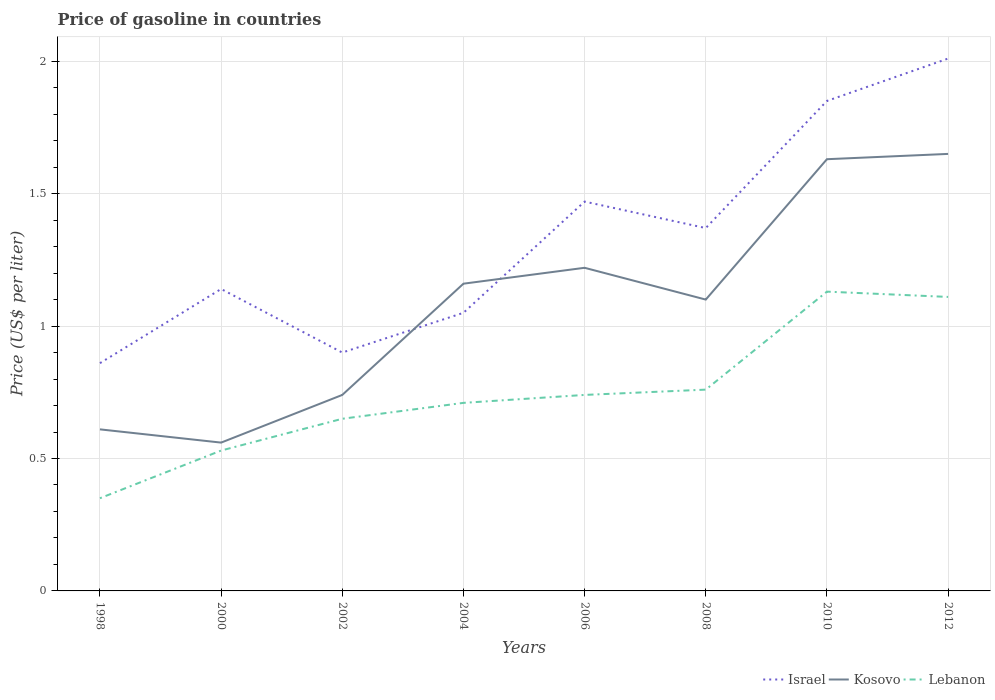How many different coloured lines are there?
Your answer should be very brief. 3. Is the number of lines equal to the number of legend labels?
Give a very brief answer. Yes. Across all years, what is the maximum price of gasoline in Israel?
Provide a short and direct response. 0.86. What is the total price of gasoline in Kosovo in the graph?
Make the answer very short. -1.02. What is the difference between the highest and the second highest price of gasoline in Israel?
Your answer should be very brief. 1.15. What is the difference between the highest and the lowest price of gasoline in Kosovo?
Give a very brief answer. 5. Is the price of gasoline in Lebanon strictly greater than the price of gasoline in Kosovo over the years?
Make the answer very short. Yes. How many lines are there?
Your answer should be compact. 3. What is the difference between two consecutive major ticks on the Y-axis?
Provide a succinct answer. 0.5. Are the values on the major ticks of Y-axis written in scientific E-notation?
Offer a very short reply. No. Does the graph contain any zero values?
Your answer should be very brief. No. Does the graph contain grids?
Keep it short and to the point. Yes. Where does the legend appear in the graph?
Give a very brief answer. Bottom right. How many legend labels are there?
Provide a succinct answer. 3. How are the legend labels stacked?
Your answer should be compact. Horizontal. What is the title of the graph?
Provide a short and direct response. Price of gasoline in countries. Does "Spain" appear as one of the legend labels in the graph?
Your answer should be very brief. No. What is the label or title of the X-axis?
Offer a terse response. Years. What is the label or title of the Y-axis?
Your response must be concise. Price (US$ per liter). What is the Price (US$ per liter) of Israel in 1998?
Give a very brief answer. 0.86. What is the Price (US$ per liter) of Kosovo in 1998?
Make the answer very short. 0.61. What is the Price (US$ per liter) of Israel in 2000?
Make the answer very short. 1.14. What is the Price (US$ per liter) of Kosovo in 2000?
Provide a succinct answer. 0.56. What is the Price (US$ per liter) of Lebanon in 2000?
Ensure brevity in your answer.  0.53. What is the Price (US$ per liter) of Kosovo in 2002?
Your response must be concise. 0.74. What is the Price (US$ per liter) in Lebanon in 2002?
Make the answer very short. 0.65. What is the Price (US$ per liter) in Israel in 2004?
Your response must be concise. 1.05. What is the Price (US$ per liter) of Kosovo in 2004?
Your answer should be compact. 1.16. What is the Price (US$ per liter) of Lebanon in 2004?
Provide a succinct answer. 0.71. What is the Price (US$ per liter) of Israel in 2006?
Your response must be concise. 1.47. What is the Price (US$ per liter) in Kosovo in 2006?
Offer a very short reply. 1.22. What is the Price (US$ per liter) of Lebanon in 2006?
Keep it short and to the point. 0.74. What is the Price (US$ per liter) in Israel in 2008?
Make the answer very short. 1.37. What is the Price (US$ per liter) in Lebanon in 2008?
Make the answer very short. 0.76. What is the Price (US$ per liter) in Israel in 2010?
Provide a short and direct response. 1.85. What is the Price (US$ per liter) in Kosovo in 2010?
Your answer should be very brief. 1.63. What is the Price (US$ per liter) of Lebanon in 2010?
Your answer should be very brief. 1.13. What is the Price (US$ per liter) in Israel in 2012?
Your answer should be very brief. 2.01. What is the Price (US$ per liter) of Kosovo in 2012?
Give a very brief answer. 1.65. What is the Price (US$ per liter) in Lebanon in 2012?
Your answer should be compact. 1.11. Across all years, what is the maximum Price (US$ per liter) in Israel?
Your answer should be compact. 2.01. Across all years, what is the maximum Price (US$ per liter) of Kosovo?
Your response must be concise. 1.65. Across all years, what is the maximum Price (US$ per liter) of Lebanon?
Offer a terse response. 1.13. Across all years, what is the minimum Price (US$ per liter) of Israel?
Offer a very short reply. 0.86. Across all years, what is the minimum Price (US$ per liter) in Kosovo?
Offer a terse response. 0.56. What is the total Price (US$ per liter) in Israel in the graph?
Offer a very short reply. 10.65. What is the total Price (US$ per liter) of Kosovo in the graph?
Provide a short and direct response. 8.67. What is the total Price (US$ per liter) of Lebanon in the graph?
Your answer should be very brief. 5.98. What is the difference between the Price (US$ per liter) in Israel in 1998 and that in 2000?
Provide a short and direct response. -0.28. What is the difference between the Price (US$ per liter) in Kosovo in 1998 and that in 2000?
Provide a short and direct response. 0.05. What is the difference between the Price (US$ per liter) of Lebanon in 1998 and that in 2000?
Offer a very short reply. -0.18. What is the difference between the Price (US$ per liter) of Israel in 1998 and that in 2002?
Make the answer very short. -0.04. What is the difference between the Price (US$ per liter) in Kosovo in 1998 and that in 2002?
Keep it short and to the point. -0.13. What is the difference between the Price (US$ per liter) of Israel in 1998 and that in 2004?
Keep it short and to the point. -0.19. What is the difference between the Price (US$ per liter) of Kosovo in 1998 and that in 2004?
Your answer should be compact. -0.55. What is the difference between the Price (US$ per liter) in Lebanon in 1998 and that in 2004?
Keep it short and to the point. -0.36. What is the difference between the Price (US$ per liter) of Israel in 1998 and that in 2006?
Your answer should be very brief. -0.61. What is the difference between the Price (US$ per liter) of Kosovo in 1998 and that in 2006?
Give a very brief answer. -0.61. What is the difference between the Price (US$ per liter) of Lebanon in 1998 and that in 2006?
Provide a short and direct response. -0.39. What is the difference between the Price (US$ per liter) in Israel in 1998 and that in 2008?
Your answer should be compact. -0.51. What is the difference between the Price (US$ per liter) in Kosovo in 1998 and that in 2008?
Your response must be concise. -0.49. What is the difference between the Price (US$ per liter) of Lebanon in 1998 and that in 2008?
Ensure brevity in your answer.  -0.41. What is the difference between the Price (US$ per liter) in Israel in 1998 and that in 2010?
Provide a succinct answer. -0.99. What is the difference between the Price (US$ per liter) of Kosovo in 1998 and that in 2010?
Offer a terse response. -1.02. What is the difference between the Price (US$ per liter) in Lebanon in 1998 and that in 2010?
Provide a succinct answer. -0.78. What is the difference between the Price (US$ per liter) in Israel in 1998 and that in 2012?
Your response must be concise. -1.15. What is the difference between the Price (US$ per liter) in Kosovo in 1998 and that in 2012?
Provide a succinct answer. -1.04. What is the difference between the Price (US$ per liter) in Lebanon in 1998 and that in 2012?
Ensure brevity in your answer.  -0.76. What is the difference between the Price (US$ per liter) of Israel in 2000 and that in 2002?
Offer a very short reply. 0.24. What is the difference between the Price (US$ per liter) of Kosovo in 2000 and that in 2002?
Provide a succinct answer. -0.18. What is the difference between the Price (US$ per liter) in Lebanon in 2000 and that in 2002?
Keep it short and to the point. -0.12. What is the difference between the Price (US$ per liter) in Israel in 2000 and that in 2004?
Provide a short and direct response. 0.09. What is the difference between the Price (US$ per liter) in Lebanon in 2000 and that in 2004?
Provide a short and direct response. -0.18. What is the difference between the Price (US$ per liter) in Israel in 2000 and that in 2006?
Keep it short and to the point. -0.33. What is the difference between the Price (US$ per liter) in Kosovo in 2000 and that in 2006?
Keep it short and to the point. -0.66. What is the difference between the Price (US$ per liter) of Lebanon in 2000 and that in 2006?
Provide a short and direct response. -0.21. What is the difference between the Price (US$ per liter) in Israel in 2000 and that in 2008?
Provide a short and direct response. -0.23. What is the difference between the Price (US$ per liter) of Kosovo in 2000 and that in 2008?
Your response must be concise. -0.54. What is the difference between the Price (US$ per liter) in Lebanon in 2000 and that in 2008?
Provide a succinct answer. -0.23. What is the difference between the Price (US$ per liter) of Israel in 2000 and that in 2010?
Provide a short and direct response. -0.71. What is the difference between the Price (US$ per liter) of Kosovo in 2000 and that in 2010?
Ensure brevity in your answer.  -1.07. What is the difference between the Price (US$ per liter) in Israel in 2000 and that in 2012?
Give a very brief answer. -0.87. What is the difference between the Price (US$ per liter) in Kosovo in 2000 and that in 2012?
Your answer should be very brief. -1.09. What is the difference between the Price (US$ per liter) in Lebanon in 2000 and that in 2012?
Ensure brevity in your answer.  -0.58. What is the difference between the Price (US$ per liter) of Israel in 2002 and that in 2004?
Give a very brief answer. -0.15. What is the difference between the Price (US$ per liter) of Kosovo in 2002 and that in 2004?
Your answer should be compact. -0.42. What is the difference between the Price (US$ per liter) of Lebanon in 2002 and that in 2004?
Your response must be concise. -0.06. What is the difference between the Price (US$ per liter) of Israel in 2002 and that in 2006?
Your answer should be very brief. -0.57. What is the difference between the Price (US$ per liter) in Kosovo in 2002 and that in 2006?
Keep it short and to the point. -0.48. What is the difference between the Price (US$ per liter) in Lebanon in 2002 and that in 2006?
Ensure brevity in your answer.  -0.09. What is the difference between the Price (US$ per liter) in Israel in 2002 and that in 2008?
Provide a short and direct response. -0.47. What is the difference between the Price (US$ per liter) in Kosovo in 2002 and that in 2008?
Provide a succinct answer. -0.36. What is the difference between the Price (US$ per liter) in Lebanon in 2002 and that in 2008?
Offer a very short reply. -0.11. What is the difference between the Price (US$ per liter) of Israel in 2002 and that in 2010?
Keep it short and to the point. -0.95. What is the difference between the Price (US$ per liter) in Kosovo in 2002 and that in 2010?
Give a very brief answer. -0.89. What is the difference between the Price (US$ per liter) of Lebanon in 2002 and that in 2010?
Give a very brief answer. -0.48. What is the difference between the Price (US$ per liter) of Israel in 2002 and that in 2012?
Provide a succinct answer. -1.11. What is the difference between the Price (US$ per liter) of Kosovo in 2002 and that in 2012?
Your response must be concise. -0.91. What is the difference between the Price (US$ per liter) in Lebanon in 2002 and that in 2012?
Offer a very short reply. -0.46. What is the difference between the Price (US$ per liter) of Israel in 2004 and that in 2006?
Your answer should be compact. -0.42. What is the difference between the Price (US$ per liter) in Kosovo in 2004 and that in 2006?
Provide a succinct answer. -0.06. What is the difference between the Price (US$ per liter) in Lebanon in 2004 and that in 2006?
Offer a terse response. -0.03. What is the difference between the Price (US$ per liter) of Israel in 2004 and that in 2008?
Ensure brevity in your answer.  -0.32. What is the difference between the Price (US$ per liter) in Kosovo in 2004 and that in 2008?
Give a very brief answer. 0.06. What is the difference between the Price (US$ per liter) of Lebanon in 2004 and that in 2008?
Keep it short and to the point. -0.05. What is the difference between the Price (US$ per liter) of Kosovo in 2004 and that in 2010?
Provide a succinct answer. -0.47. What is the difference between the Price (US$ per liter) of Lebanon in 2004 and that in 2010?
Provide a short and direct response. -0.42. What is the difference between the Price (US$ per liter) of Israel in 2004 and that in 2012?
Your answer should be very brief. -0.96. What is the difference between the Price (US$ per liter) in Kosovo in 2004 and that in 2012?
Give a very brief answer. -0.49. What is the difference between the Price (US$ per liter) in Lebanon in 2004 and that in 2012?
Your answer should be compact. -0.4. What is the difference between the Price (US$ per liter) of Israel in 2006 and that in 2008?
Your answer should be very brief. 0.1. What is the difference between the Price (US$ per liter) in Kosovo in 2006 and that in 2008?
Provide a short and direct response. 0.12. What is the difference between the Price (US$ per liter) in Lebanon in 2006 and that in 2008?
Give a very brief answer. -0.02. What is the difference between the Price (US$ per liter) in Israel in 2006 and that in 2010?
Offer a terse response. -0.38. What is the difference between the Price (US$ per liter) of Kosovo in 2006 and that in 2010?
Offer a very short reply. -0.41. What is the difference between the Price (US$ per liter) in Lebanon in 2006 and that in 2010?
Your answer should be compact. -0.39. What is the difference between the Price (US$ per liter) in Israel in 2006 and that in 2012?
Provide a short and direct response. -0.54. What is the difference between the Price (US$ per liter) in Kosovo in 2006 and that in 2012?
Provide a succinct answer. -0.43. What is the difference between the Price (US$ per liter) of Lebanon in 2006 and that in 2012?
Offer a terse response. -0.37. What is the difference between the Price (US$ per liter) of Israel in 2008 and that in 2010?
Your answer should be compact. -0.48. What is the difference between the Price (US$ per liter) of Kosovo in 2008 and that in 2010?
Ensure brevity in your answer.  -0.53. What is the difference between the Price (US$ per liter) of Lebanon in 2008 and that in 2010?
Offer a very short reply. -0.37. What is the difference between the Price (US$ per liter) of Israel in 2008 and that in 2012?
Make the answer very short. -0.64. What is the difference between the Price (US$ per liter) in Kosovo in 2008 and that in 2012?
Offer a terse response. -0.55. What is the difference between the Price (US$ per liter) in Lebanon in 2008 and that in 2012?
Your answer should be compact. -0.35. What is the difference between the Price (US$ per liter) of Israel in 2010 and that in 2012?
Ensure brevity in your answer.  -0.16. What is the difference between the Price (US$ per liter) in Kosovo in 2010 and that in 2012?
Offer a very short reply. -0.02. What is the difference between the Price (US$ per liter) of Israel in 1998 and the Price (US$ per liter) of Lebanon in 2000?
Provide a short and direct response. 0.33. What is the difference between the Price (US$ per liter) in Kosovo in 1998 and the Price (US$ per liter) in Lebanon in 2000?
Provide a succinct answer. 0.08. What is the difference between the Price (US$ per liter) of Israel in 1998 and the Price (US$ per liter) of Kosovo in 2002?
Make the answer very short. 0.12. What is the difference between the Price (US$ per liter) of Israel in 1998 and the Price (US$ per liter) of Lebanon in 2002?
Provide a succinct answer. 0.21. What is the difference between the Price (US$ per liter) in Kosovo in 1998 and the Price (US$ per liter) in Lebanon in 2002?
Give a very brief answer. -0.04. What is the difference between the Price (US$ per liter) of Israel in 1998 and the Price (US$ per liter) of Kosovo in 2004?
Offer a very short reply. -0.3. What is the difference between the Price (US$ per liter) of Israel in 1998 and the Price (US$ per liter) of Lebanon in 2004?
Your answer should be very brief. 0.15. What is the difference between the Price (US$ per liter) of Kosovo in 1998 and the Price (US$ per liter) of Lebanon in 2004?
Your answer should be very brief. -0.1. What is the difference between the Price (US$ per liter) in Israel in 1998 and the Price (US$ per liter) in Kosovo in 2006?
Offer a very short reply. -0.36. What is the difference between the Price (US$ per liter) of Israel in 1998 and the Price (US$ per liter) of Lebanon in 2006?
Ensure brevity in your answer.  0.12. What is the difference between the Price (US$ per liter) of Kosovo in 1998 and the Price (US$ per liter) of Lebanon in 2006?
Make the answer very short. -0.13. What is the difference between the Price (US$ per liter) in Israel in 1998 and the Price (US$ per liter) in Kosovo in 2008?
Provide a succinct answer. -0.24. What is the difference between the Price (US$ per liter) of Kosovo in 1998 and the Price (US$ per liter) of Lebanon in 2008?
Your response must be concise. -0.15. What is the difference between the Price (US$ per liter) of Israel in 1998 and the Price (US$ per liter) of Kosovo in 2010?
Offer a terse response. -0.77. What is the difference between the Price (US$ per liter) of Israel in 1998 and the Price (US$ per liter) of Lebanon in 2010?
Your response must be concise. -0.27. What is the difference between the Price (US$ per liter) of Kosovo in 1998 and the Price (US$ per liter) of Lebanon in 2010?
Make the answer very short. -0.52. What is the difference between the Price (US$ per liter) of Israel in 1998 and the Price (US$ per liter) of Kosovo in 2012?
Offer a terse response. -0.79. What is the difference between the Price (US$ per liter) in Israel in 2000 and the Price (US$ per liter) in Lebanon in 2002?
Your response must be concise. 0.49. What is the difference between the Price (US$ per liter) of Kosovo in 2000 and the Price (US$ per liter) of Lebanon in 2002?
Ensure brevity in your answer.  -0.09. What is the difference between the Price (US$ per liter) of Israel in 2000 and the Price (US$ per liter) of Kosovo in 2004?
Give a very brief answer. -0.02. What is the difference between the Price (US$ per liter) in Israel in 2000 and the Price (US$ per liter) in Lebanon in 2004?
Your answer should be very brief. 0.43. What is the difference between the Price (US$ per liter) in Kosovo in 2000 and the Price (US$ per liter) in Lebanon in 2004?
Your answer should be very brief. -0.15. What is the difference between the Price (US$ per liter) in Israel in 2000 and the Price (US$ per liter) in Kosovo in 2006?
Ensure brevity in your answer.  -0.08. What is the difference between the Price (US$ per liter) in Israel in 2000 and the Price (US$ per liter) in Lebanon in 2006?
Provide a short and direct response. 0.4. What is the difference between the Price (US$ per liter) of Kosovo in 2000 and the Price (US$ per liter) of Lebanon in 2006?
Offer a terse response. -0.18. What is the difference between the Price (US$ per liter) of Israel in 2000 and the Price (US$ per liter) of Lebanon in 2008?
Keep it short and to the point. 0.38. What is the difference between the Price (US$ per liter) in Kosovo in 2000 and the Price (US$ per liter) in Lebanon in 2008?
Ensure brevity in your answer.  -0.2. What is the difference between the Price (US$ per liter) in Israel in 2000 and the Price (US$ per liter) in Kosovo in 2010?
Make the answer very short. -0.49. What is the difference between the Price (US$ per liter) of Israel in 2000 and the Price (US$ per liter) of Lebanon in 2010?
Offer a terse response. 0.01. What is the difference between the Price (US$ per liter) in Kosovo in 2000 and the Price (US$ per liter) in Lebanon in 2010?
Your answer should be compact. -0.57. What is the difference between the Price (US$ per liter) in Israel in 2000 and the Price (US$ per liter) in Kosovo in 2012?
Your response must be concise. -0.51. What is the difference between the Price (US$ per liter) of Kosovo in 2000 and the Price (US$ per liter) of Lebanon in 2012?
Ensure brevity in your answer.  -0.55. What is the difference between the Price (US$ per liter) of Israel in 2002 and the Price (US$ per liter) of Kosovo in 2004?
Provide a short and direct response. -0.26. What is the difference between the Price (US$ per liter) in Israel in 2002 and the Price (US$ per liter) in Lebanon in 2004?
Provide a short and direct response. 0.19. What is the difference between the Price (US$ per liter) in Israel in 2002 and the Price (US$ per liter) in Kosovo in 2006?
Ensure brevity in your answer.  -0.32. What is the difference between the Price (US$ per liter) of Israel in 2002 and the Price (US$ per liter) of Lebanon in 2006?
Your response must be concise. 0.16. What is the difference between the Price (US$ per liter) of Kosovo in 2002 and the Price (US$ per liter) of Lebanon in 2006?
Your answer should be compact. 0. What is the difference between the Price (US$ per liter) of Israel in 2002 and the Price (US$ per liter) of Lebanon in 2008?
Offer a terse response. 0.14. What is the difference between the Price (US$ per liter) of Kosovo in 2002 and the Price (US$ per liter) of Lebanon in 2008?
Make the answer very short. -0.02. What is the difference between the Price (US$ per liter) in Israel in 2002 and the Price (US$ per liter) in Kosovo in 2010?
Keep it short and to the point. -0.73. What is the difference between the Price (US$ per liter) of Israel in 2002 and the Price (US$ per liter) of Lebanon in 2010?
Your answer should be compact. -0.23. What is the difference between the Price (US$ per liter) of Kosovo in 2002 and the Price (US$ per liter) of Lebanon in 2010?
Provide a short and direct response. -0.39. What is the difference between the Price (US$ per liter) in Israel in 2002 and the Price (US$ per liter) in Kosovo in 2012?
Make the answer very short. -0.75. What is the difference between the Price (US$ per liter) in Israel in 2002 and the Price (US$ per liter) in Lebanon in 2012?
Keep it short and to the point. -0.21. What is the difference between the Price (US$ per liter) of Kosovo in 2002 and the Price (US$ per liter) of Lebanon in 2012?
Ensure brevity in your answer.  -0.37. What is the difference between the Price (US$ per liter) in Israel in 2004 and the Price (US$ per liter) in Kosovo in 2006?
Ensure brevity in your answer.  -0.17. What is the difference between the Price (US$ per liter) in Israel in 2004 and the Price (US$ per liter) in Lebanon in 2006?
Give a very brief answer. 0.31. What is the difference between the Price (US$ per liter) in Kosovo in 2004 and the Price (US$ per liter) in Lebanon in 2006?
Offer a very short reply. 0.42. What is the difference between the Price (US$ per liter) in Israel in 2004 and the Price (US$ per liter) in Kosovo in 2008?
Your response must be concise. -0.05. What is the difference between the Price (US$ per liter) in Israel in 2004 and the Price (US$ per liter) in Lebanon in 2008?
Your answer should be very brief. 0.29. What is the difference between the Price (US$ per liter) in Kosovo in 2004 and the Price (US$ per liter) in Lebanon in 2008?
Your answer should be compact. 0.4. What is the difference between the Price (US$ per liter) of Israel in 2004 and the Price (US$ per liter) of Kosovo in 2010?
Offer a very short reply. -0.58. What is the difference between the Price (US$ per liter) of Israel in 2004 and the Price (US$ per liter) of Lebanon in 2010?
Give a very brief answer. -0.08. What is the difference between the Price (US$ per liter) in Israel in 2004 and the Price (US$ per liter) in Kosovo in 2012?
Your response must be concise. -0.6. What is the difference between the Price (US$ per liter) in Israel in 2004 and the Price (US$ per liter) in Lebanon in 2012?
Your answer should be compact. -0.06. What is the difference between the Price (US$ per liter) of Israel in 2006 and the Price (US$ per liter) of Kosovo in 2008?
Offer a terse response. 0.37. What is the difference between the Price (US$ per liter) in Israel in 2006 and the Price (US$ per liter) in Lebanon in 2008?
Provide a succinct answer. 0.71. What is the difference between the Price (US$ per liter) of Kosovo in 2006 and the Price (US$ per liter) of Lebanon in 2008?
Offer a terse response. 0.46. What is the difference between the Price (US$ per liter) in Israel in 2006 and the Price (US$ per liter) in Kosovo in 2010?
Keep it short and to the point. -0.16. What is the difference between the Price (US$ per liter) in Israel in 2006 and the Price (US$ per liter) in Lebanon in 2010?
Ensure brevity in your answer.  0.34. What is the difference between the Price (US$ per liter) in Kosovo in 2006 and the Price (US$ per liter) in Lebanon in 2010?
Make the answer very short. 0.09. What is the difference between the Price (US$ per liter) of Israel in 2006 and the Price (US$ per liter) of Kosovo in 2012?
Keep it short and to the point. -0.18. What is the difference between the Price (US$ per liter) in Israel in 2006 and the Price (US$ per liter) in Lebanon in 2012?
Give a very brief answer. 0.36. What is the difference between the Price (US$ per liter) in Kosovo in 2006 and the Price (US$ per liter) in Lebanon in 2012?
Your answer should be compact. 0.11. What is the difference between the Price (US$ per liter) of Israel in 2008 and the Price (US$ per liter) of Kosovo in 2010?
Provide a succinct answer. -0.26. What is the difference between the Price (US$ per liter) in Israel in 2008 and the Price (US$ per liter) in Lebanon in 2010?
Ensure brevity in your answer.  0.24. What is the difference between the Price (US$ per liter) of Kosovo in 2008 and the Price (US$ per liter) of Lebanon in 2010?
Make the answer very short. -0.03. What is the difference between the Price (US$ per liter) in Israel in 2008 and the Price (US$ per liter) in Kosovo in 2012?
Provide a short and direct response. -0.28. What is the difference between the Price (US$ per liter) in Israel in 2008 and the Price (US$ per liter) in Lebanon in 2012?
Make the answer very short. 0.26. What is the difference between the Price (US$ per liter) in Kosovo in 2008 and the Price (US$ per liter) in Lebanon in 2012?
Give a very brief answer. -0.01. What is the difference between the Price (US$ per liter) in Israel in 2010 and the Price (US$ per liter) in Lebanon in 2012?
Your answer should be very brief. 0.74. What is the difference between the Price (US$ per liter) of Kosovo in 2010 and the Price (US$ per liter) of Lebanon in 2012?
Make the answer very short. 0.52. What is the average Price (US$ per liter) of Israel per year?
Ensure brevity in your answer.  1.33. What is the average Price (US$ per liter) of Kosovo per year?
Your answer should be very brief. 1.08. What is the average Price (US$ per liter) in Lebanon per year?
Your response must be concise. 0.75. In the year 1998, what is the difference between the Price (US$ per liter) of Israel and Price (US$ per liter) of Kosovo?
Your response must be concise. 0.25. In the year 1998, what is the difference between the Price (US$ per liter) in Israel and Price (US$ per liter) in Lebanon?
Offer a terse response. 0.51. In the year 1998, what is the difference between the Price (US$ per liter) in Kosovo and Price (US$ per liter) in Lebanon?
Keep it short and to the point. 0.26. In the year 2000, what is the difference between the Price (US$ per liter) of Israel and Price (US$ per liter) of Kosovo?
Ensure brevity in your answer.  0.58. In the year 2000, what is the difference between the Price (US$ per liter) of Israel and Price (US$ per liter) of Lebanon?
Provide a succinct answer. 0.61. In the year 2000, what is the difference between the Price (US$ per liter) of Kosovo and Price (US$ per liter) of Lebanon?
Provide a short and direct response. 0.03. In the year 2002, what is the difference between the Price (US$ per liter) in Israel and Price (US$ per liter) in Kosovo?
Ensure brevity in your answer.  0.16. In the year 2002, what is the difference between the Price (US$ per liter) of Kosovo and Price (US$ per liter) of Lebanon?
Offer a terse response. 0.09. In the year 2004, what is the difference between the Price (US$ per liter) of Israel and Price (US$ per liter) of Kosovo?
Give a very brief answer. -0.11. In the year 2004, what is the difference between the Price (US$ per liter) of Israel and Price (US$ per liter) of Lebanon?
Ensure brevity in your answer.  0.34. In the year 2004, what is the difference between the Price (US$ per liter) of Kosovo and Price (US$ per liter) of Lebanon?
Offer a terse response. 0.45. In the year 2006, what is the difference between the Price (US$ per liter) of Israel and Price (US$ per liter) of Lebanon?
Provide a succinct answer. 0.73. In the year 2006, what is the difference between the Price (US$ per liter) of Kosovo and Price (US$ per liter) of Lebanon?
Your answer should be compact. 0.48. In the year 2008, what is the difference between the Price (US$ per liter) of Israel and Price (US$ per liter) of Kosovo?
Ensure brevity in your answer.  0.27. In the year 2008, what is the difference between the Price (US$ per liter) of Israel and Price (US$ per liter) of Lebanon?
Your answer should be very brief. 0.61. In the year 2008, what is the difference between the Price (US$ per liter) in Kosovo and Price (US$ per liter) in Lebanon?
Give a very brief answer. 0.34. In the year 2010, what is the difference between the Price (US$ per liter) in Israel and Price (US$ per liter) in Kosovo?
Make the answer very short. 0.22. In the year 2010, what is the difference between the Price (US$ per liter) in Israel and Price (US$ per liter) in Lebanon?
Your answer should be very brief. 0.72. In the year 2012, what is the difference between the Price (US$ per liter) in Israel and Price (US$ per liter) in Kosovo?
Offer a terse response. 0.36. In the year 2012, what is the difference between the Price (US$ per liter) of Kosovo and Price (US$ per liter) of Lebanon?
Ensure brevity in your answer.  0.54. What is the ratio of the Price (US$ per liter) in Israel in 1998 to that in 2000?
Offer a terse response. 0.75. What is the ratio of the Price (US$ per liter) of Kosovo in 1998 to that in 2000?
Provide a short and direct response. 1.09. What is the ratio of the Price (US$ per liter) of Lebanon in 1998 to that in 2000?
Provide a succinct answer. 0.66. What is the ratio of the Price (US$ per liter) of Israel in 1998 to that in 2002?
Keep it short and to the point. 0.96. What is the ratio of the Price (US$ per liter) of Kosovo in 1998 to that in 2002?
Offer a terse response. 0.82. What is the ratio of the Price (US$ per liter) of Lebanon in 1998 to that in 2002?
Give a very brief answer. 0.54. What is the ratio of the Price (US$ per liter) of Israel in 1998 to that in 2004?
Make the answer very short. 0.82. What is the ratio of the Price (US$ per liter) of Kosovo in 1998 to that in 2004?
Provide a short and direct response. 0.53. What is the ratio of the Price (US$ per liter) of Lebanon in 1998 to that in 2004?
Your answer should be very brief. 0.49. What is the ratio of the Price (US$ per liter) in Israel in 1998 to that in 2006?
Ensure brevity in your answer.  0.58. What is the ratio of the Price (US$ per liter) of Lebanon in 1998 to that in 2006?
Ensure brevity in your answer.  0.47. What is the ratio of the Price (US$ per liter) of Israel in 1998 to that in 2008?
Offer a terse response. 0.63. What is the ratio of the Price (US$ per liter) of Kosovo in 1998 to that in 2008?
Give a very brief answer. 0.55. What is the ratio of the Price (US$ per liter) of Lebanon in 1998 to that in 2008?
Ensure brevity in your answer.  0.46. What is the ratio of the Price (US$ per liter) in Israel in 1998 to that in 2010?
Provide a succinct answer. 0.46. What is the ratio of the Price (US$ per liter) in Kosovo in 1998 to that in 2010?
Ensure brevity in your answer.  0.37. What is the ratio of the Price (US$ per liter) of Lebanon in 1998 to that in 2010?
Provide a short and direct response. 0.31. What is the ratio of the Price (US$ per liter) of Israel in 1998 to that in 2012?
Offer a very short reply. 0.43. What is the ratio of the Price (US$ per liter) of Kosovo in 1998 to that in 2012?
Provide a short and direct response. 0.37. What is the ratio of the Price (US$ per liter) of Lebanon in 1998 to that in 2012?
Offer a terse response. 0.32. What is the ratio of the Price (US$ per liter) in Israel in 2000 to that in 2002?
Make the answer very short. 1.27. What is the ratio of the Price (US$ per liter) in Kosovo in 2000 to that in 2002?
Your answer should be compact. 0.76. What is the ratio of the Price (US$ per liter) of Lebanon in 2000 to that in 2002?
Your answer should be very brief. 0.82. What is the ratio of the Price (US$ per liter) of Israel in 2000 to that in 2004?
Your answer should be very brief. 1.09. What is the ratio of the Price (US$ per liter) in Kosovo in 2000 to that in 2004?
Make the answer very short. 0.48. What is the ratio of the Price (US$ per liter) of Lebanon in 2000 to that in 2004?
Offer a very short reply. 0.75. What is the ratio of the Price (US$ per liter) in Israel in 2000 to that in 2006?
Your answer should be compact. 0.78. What is the ratio of the Price (US$ per liter) in Kosovo in 2000 to that in 2006?
Keep it short and to the point. 0.46. What is the ratio of the Price (US$ per liter) of Lebanon in 2000 to that in 2006?
Your answer should be very brief. 0.72. What is the ratio of the Price (US$ per liter) in Israel in 2000 to that in 2008?
Make the answer very short. 0.83. What is the ratio of the Price (US$ per liter) in Kosovo in 2000 to that in 2008?
Offer a very short reply. 0.51. What is the ratio of the Price (US$ per liter) of Lebanon in 2000 to that in 2008?
Your answer should be compact. 0.7. What is the ratio of the Price (US$ per liter) of Israel in 2000 to that in 2010?
Offer a very short reply. 0.62. What is the ratio of the Price (US$ per liter) of Kosovo in 2000 to that in 2010?
Provide a succinct answer. 0.34. What is the ratio of the Price (US$ per liter) in Lebanon in 2000 to that in 2010?
Keep it short and to the point. 0.47. What is the ratio of the Price (US$ per liter) in Israel in 2000 to that in 2012?
Make the answer very short. 0.57. What is the ratio of the Price (US$ per liter) of Kosovo in 2000 to that in 2012?
Offer a terse response. 0.34. What is the ratio of the Price (US$ per liter) of Lebanon in 2000 to that in 2012?
Provide a succinct answer. 0.48. What is the ratio of the Price (US$ per liter) in Israel in 2002 to that in 2004?
Your answer should be very brief. 0.86. What is the ratio of the Price (US$ per liter) in Kosovo in 2002 to that in 2004?
Give a very brief answer. 0.64. What is the ratio of the Price (US$ per liter) in Lebanon in 2002 to that in 2004?
Provide a short and direct response. 0.92. What is the ratio of the Price (US$ per liter) of Israel in 2002 to that in 2006?
Provide a short and direct response. 0.61. What is the ratio of the Price (US$ per liter) in Kosovo in 2002 to that in 2006?
Provide a short and direct response. 0.61. What is the ratio of the Price (US$ per liter) in Lebanon in 2002 to that in 2006?
Your answer should be very brief. 0.88. What is the ratio of the Price (US$ per liter) of Israel in 2002 to that in 2008?
Ensure brevity in your answer.  0.66. What is the ratio of the Price (US$ per liter) of Kosovo in 2002 to that in 2008?
Offer a very short reply. 0.67. What is the ratio of the Price (US$ per liter) of Lebanon in 2002 to that in 2008?
Offer a very short reply. 0.86. What is the ratio of the Price (US$ per liter) of Israel in 2002 to that in 2010?
Your answer should be very brief. 0.49. What is the ratio of the Price (US$ per liter) in Kosovo in 2002 to that in 2010?
Offer a terse response. 0.45. What is the ratio of the Price (US$ per liter) in Lebanon in 2002 to that in 2010?
Your answer should be very brief. 0.58. What is the ratio of the Price (US$ per liter) in Israel in 2002 to that in 2012?
Your answer should be very brief. 0.45. What is the ratio of the Price (US$ per liter) in Kosovo in 2002 to that in 2012?
Provide a short and direct response. 0.45. What is the ratio of the Price (US$ per liter) of Lebanon in 2002 to that in 2012?
Your response must be concise. 0.59. What is the ratio of the Price (US$ per liter) of Israel in 2004 to that in 2006?
Offer a very short reply. 0.71. What is the ratio of the Price (US$ per liter) in Kosovo in 2004 to that in 2006?
Keep it short and to the point. 0.95. What is the ratio of the Price (US$ per liter) of Lebanon in 2004 to that in 2006?
Offer a terse response. 0.96. What is the ratio of the Price (US$ per liter) of Israel in 2004 to that in 2008?
Ensure brevity in your answer.  0.77. What is the ratio of the Price (US$ per liter) in Kosovo in 2004 to that in 2008?
Ensure brevity in your answer.  1.05. What is the ratio of the Price (US$ per liter) of Lebanon in 2004 to that in 2008?
Keep it short and to the point. 0.93. What is the ratio of the Price (US$ per liter) of Israel in 2004 to that in 2010?
Ensure brevity in your answer.  0.57. What is the ratio of the Price (US$ per liter) in Kosovo in 2004 to that in 2010?
Ensure brevity in your answer.  0.71. What is the ratio of the Price (US$ per liter) of Lebanon in 2004 to that in 2010?
Your answer should be compact. 0.63. What is the ratio of the Price (US$ per liter) of Israel in 2004 to that in 2012?
Your answer should be compact. 0.52. What is the ratio of the Price (US$ per liter) of Kosovo in 2004 to that in 2012?
Ensure brevity in your answer.  0.7. What is the ratio of the Price (US$ per liter) in Lebanon in 2004 to that in 2012?
Your answer should be compact. 0.64. What is the ratio of the Price (US$ per liter) in Israel in 2006 to that in 2008?
Your response must be concise. 1.07. What is the ratio of the Price (US$ per liter) of Kosovo in 2006 to that in 2008?
Offer a terse response. 1.11. What is the ratio of the Price (US$ per liter) in Lebanon in 2006 to that in 2008?
Provide a succinct answer. 0.97. What is the ratio of the Price (US$ per liter) of Israel in 2006 to that in 2010?
Your answer should be compact. 0.79. What is the ratio of the Price (US$ per liter) in Kosovo in 2006 to that in 2010?
Provide a succinct answer. 0.75. What is the ratio of the Price (US$ per liter) in Lebanon in 2006 to that in 2010?
Keep it short and to the point. 0.65. What is the ratio of the Price (US$ per liter) of Israel in 2006 to that in 2012?
Keep it short and to the point. 0.73. What is the ratio of the Price (US$ per liter) of Kosovo in 2006 to that in 2012?
Offer a very short reply. 0.74. What is the ratio of the Price (US$ per liter) of Israel in 2008 to that in 2010?
Give a very brief answer. 0.74. What is the ratio of the Price (US$ per liter) of Kosovo in 2008 to that in 2010?
Offer a very short reply. 0.67. What is the ratio of the Price (US$ per liter) of Lebanon in 2008 to that in 2010?
Ensure brevity in your answer.  0.67. What is the ratio of the Price (US$ per liter) in Israel in 2008 to that in 2012?
Make the answer very short. 0.68. What is the ratio of the Price (US$ per liter) of Kosovo in 2008 to that in 2012?
Your answer should be compact. 0.67. What is the ratio of the Price (US$ per liter) of Lebanon in 2008 to that in 2012?
Your answer should be compact. 0.68. What is the ratio of the Price (US$ per liter) of Israel in 2010 to that in 2012?
Your response must be concise. 0.92. What is the ratio of the Price (US$ per liter) in Kosovo in 2010 to that in 2012?
Offer a very short reply. 0.99. What is the difference between the highest and the second highest Price (US$ per liter) of Israel?
Offer a terse response. 0.16. What is the difference between the highest and the second highest Price (US$ per liter) of Kosovo?
Offer a terse response. 0.02. What is the difference between the highest and the second highest Price (US$ per liter) in Lebanon?
Provide a short and direct response. 0.02. What is the difference between the highest and the lowest Price (US$ per liter) of Israel?
Give a very brief answer. 1.15. What is the difference between the highest and the lowest Price (US$ per liter) in Kosovo?
Ensure brevity in your answer.  1.09. What is the difference between the highest and the lowest Price (US$ per liter) of Lebanon?
Offer a very short reply. 0.78. 